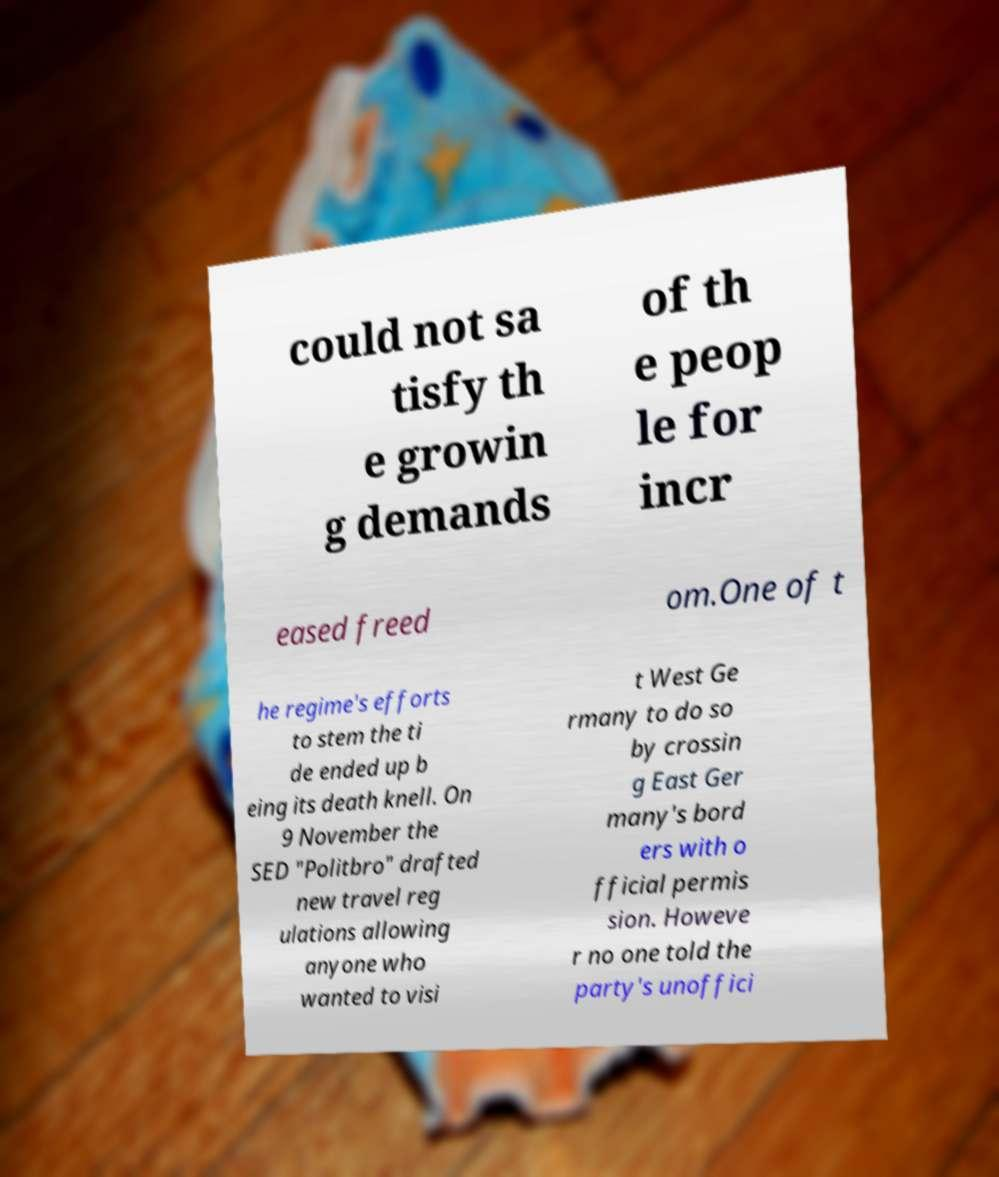For documentation purposes, I need the text within this image transcribed. Could you provide that? could not sa tisfy th e growin g demands of th e peop le for incr eased freed om.One of t he regime's efforts to stem the ti de ended up b eing its death knell. On 9 November the SED "Politbro" drafted new travel reg ulations allowing anyone who wanted to visi t West Ge rmany to do so by crossin g East Ger many's bord ers with o fficial permis sion. Howeve r no one told the party's unoffici 